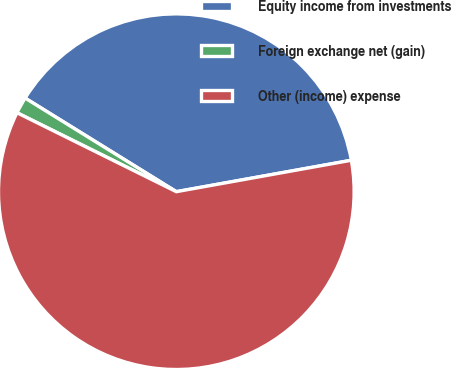Convert chart. <chart><loc_0><loc_0><loc_500><loc_500><pie_chart><fcel>Equity income from investments<fcel>Foreign exchange net (gain)<fcel>Other (income) expense<nl><fcel>38.35%<fcel>1.5%<fcel>60.15%<nl></chart> 